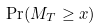<formula> <loc_0><loc_0><loc_500><loc_500>\Pr ( M _ { T } \geq x )</formula> 